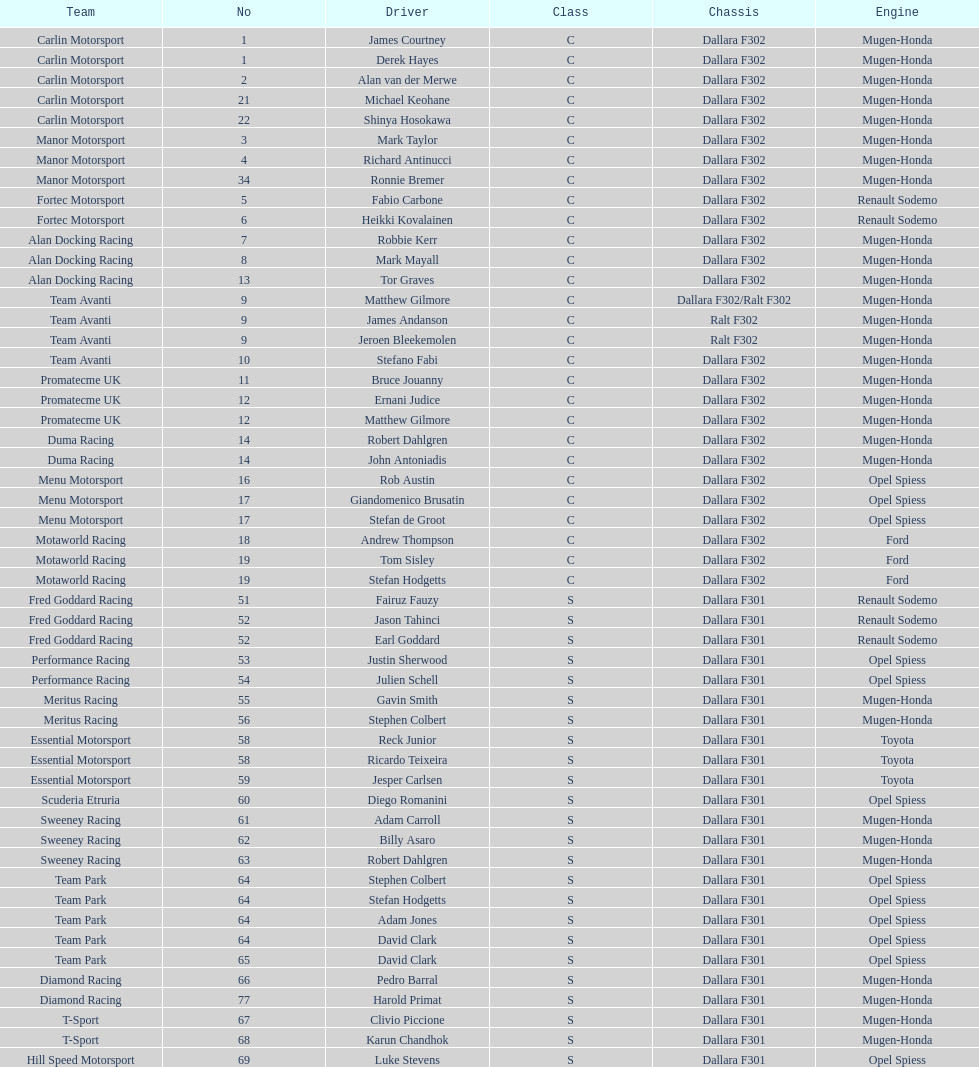How many teams had at least two drivers this season? 17. 